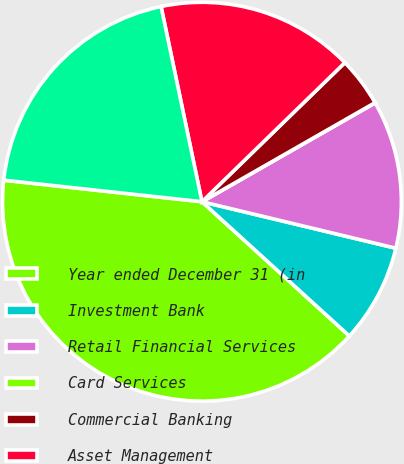Convert chart to OTSL. <chart><loc_0><loc_0><loc_500><loc_500><pie_chart><fcel>Year ended December 31 (in<fcel>Investment Bank<fcel>Retail Financial Services<fcel>Card Services<fcel>Commercial Banking<fcel>Asset Management<fcel>Corporate/Private Equity<nl><fcel>39.96%<fcel>8.01%<fcel>12.0%<fcel>0.02%<fcel>4.01%<fcel>16.0%<fcel>19.99%<nl></chart> 